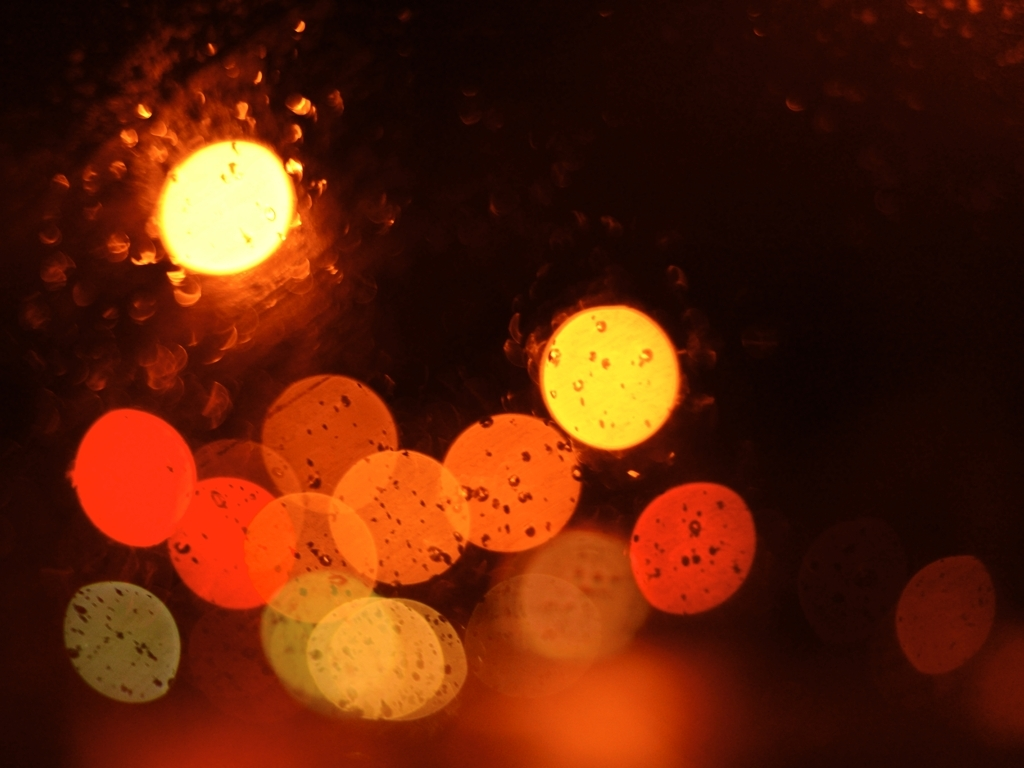What time of day does this image likely depict? Based on the warm color tones and the diffused lighting, this image likely captures a scene at night. The glares suggest artificial street or vehicle lights, often seen during evening or nighttime in a rainy urban setting. What is the mood conveyed by this image? The image conveys a moody, introspective atmosphere. The interplay of light and shadow, along with the raindrops, can evoke feelings of solitude or contemplation often associated with rainy nights. 